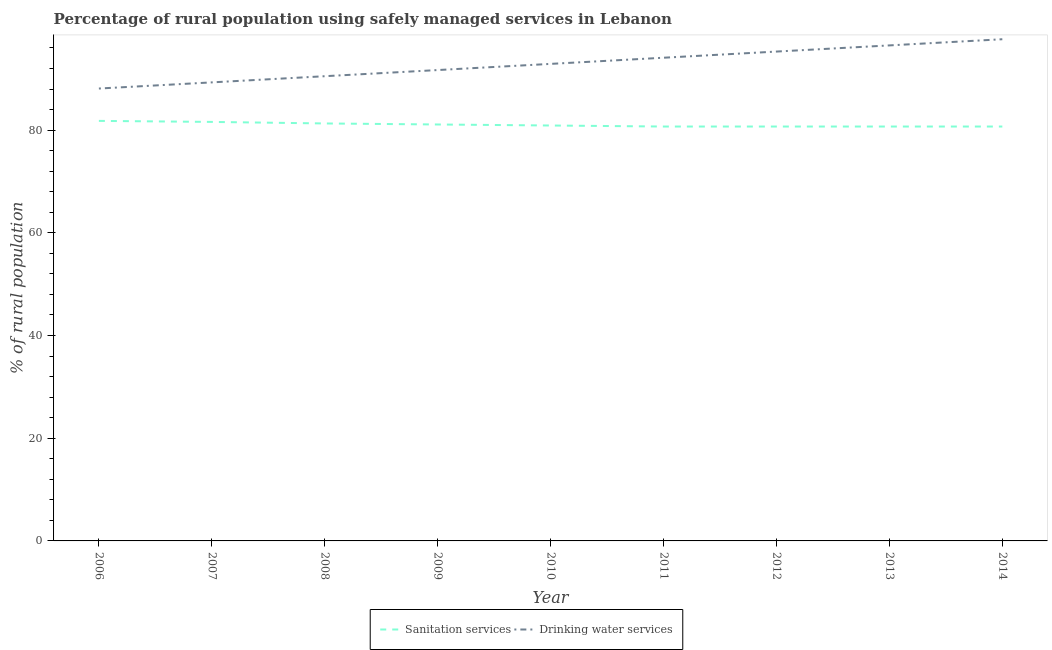How many different coloured lines are there?
Give a very brief answer. 2. Is the number of lines equal to the number of legend labels?
Offer a terse response. Yes. What is the percentage of rural population who used sanitation services in 2010?
Offer a terse response. 80.9. Across all years, what is the maximum percentage of rural population who used drinking water services?
Your answer should be very brief. 97.7. Across all years, what is the minimum percentage of rural population who used drinking water services?
Provide a short and direct response. 88.1. In which year was the percentage of rural population who used drinking water services maximum?
Ensure brevity in your answer.  2014. In which year was the percentage of rural population who used sanitation services minimum?
Your response must be concise. 2011. What is the total percentage of rural population who used sanitation services in the graph?
Your answer should be compact. 729.5. What is the difference between the percentage of rural population who used sanitation services in 2006 and that in 2012?
Keep it short and to the point. 1.1. What is the difference between the percentage of rural population who used drinking water services in 2011 and the percentage of rural population who used sanitation services in 2009?
Your response must be concise. 13. What is the average percentage of rural population who used drinking water services per year?
Offer a terse response. 92.9. In the year 2007, what is the difference between the percentage of rural population who used drinking water services and percentage of rural population who used sanitation services?
Make the answer very short. 7.7. What is the ratio of the percentage of rural population who used sanitation services in 2008 to that in 2014?
Provide a short and direct response. 1.01. Is the percentage of rural population who used drinking water services in 2007 less than that in 2008?
Give a very brief answer. Yes. What is the difference between the highest and the second highest percentage of rural population who used sanitation services?
Ensure brevity in your answer.  0.2. What is the difference between the highest and the lowest percentage of rural population who used drinking water services?
Make the answer very short. 9.6. Does the percentage of rural population who used drinking water services monotonically increase over the years?
Ensure brevity in your answer.  Yes. How many years are there in the graph?
Your answer should be very brief. 9. What is the difference between two consecutive major ticks on the Y-axis?
Keep it short and to the point. 20. Are the values on the major ticks of Y-axis written in scientific E-notation?
Give a very brief answer. No. Does the graph contain any zero values?
Give a very brief answer. No. How are the legend labels stacked?
Provide a short and direct response. Horizontal. What is the title of the graph?
Make the answer very short. Percentage of rural population using safely managed services in Lebanon. Does "Death rate" appear as one of the legend labels in the graph?
Ensure brevity in your answer.  No. What is the label or title of the Y-axis?
Your response must be concise. % of rural population. What is the % of rural population in Sanitation services in 2006?
Ensure brevity in your answer.  81.8. What is the % of rural population of Drinking water services in 2006?
Offer a terse response. 88.1. What is the % of rural population in Sanitation services in 2007?
Your answer should be very brief. 81.6. What is the % of rural population in Drinking water services in 2007?
Ensure brevity in your answer.  89.3. What is the % of rural population in Sanitation services in 2008?
Your answer should be very brief. 81.3. What is the % of rural population in Drinking water services in 2008?
Ensure brevity in your answer.  90.5. What is the % of rural population in Sanitation services in 2009?
Ensure brevity in your answer.  81.1. What is the % of rural population in Drinking water services in 2009?
Your response must be concise. 91.7. What is the % of rural population in Sanitation services in 2010?
Provide a succinct answer. 80.9. What is the % of rural population of Drinking water services in 2010?
Your response must be concise. 92.9. What is the % of rural population in Sanitation services in 2011?
Your response must be concise. 80.7. What is the % of rural population of Drinking water services in 2011?
Your answer should be very brief. 94.1. What is the % of rural population of Sanitation services in 2012?
Provide a succinct answer. 80.7. What is the % of rural population of Drinking water services in 2012?
Offer a terse response. 95.3. What is the % of rural population of Sanitation services in 2013?
Provide a short and direct response. 80.7. What is the % of rural population of Drinking water services in 2013?
Provide a short and direct response. 96.5. What is the % of rural population in Sanitation services in 2014?
Your response must be concise. 80.7. What is the % of rural population in Drinking water services in 2014?
Your answer should be compact. 97.7. Across all years, what is the maximum % of rural population of Sanitation services?
Provide a succinct answer. 81.8. Across all years, what is the maximum % of rural population in Drinking water services?
Offer a very short reply. 97.7. Across all years, what is the minimum % of rural population in Sanitation services?
Keep it short and to the point. 80.7. Across all years, what is the minimum % of rural population of Drinking water services?
Keep it short and to the point. 88.1. What is the total % of rural population of Sanitation services in the graph?
Offer a terse response. 729.5. What is the total % of rural population of Drinking water services in the graph?
Provide a succinct answer. 836.1. What is the difference between the % of rural population of Sanitation services in 2006 and that in 2009?
Ensure brevity in your answer.  0.7. What is the difference between the % of rural population of Drinking water services in 2006 and that in 2009?
Make the answer very short. -3.6. What is the difference between the % of rural population of Sanitation services in 2006 and that in 2010?
Give a very brief answer. 0.9. What is the difference between the % of rural population in Drinking water services in 2006 and that in 2011?
Your answer should be very brief. -6. What is the difference between the % of rural population in Sanitation services in 2006 and that in 2012?
Give a very brief answer. 1.1. What is the difference between the % of rural population in Drinking water services in 2006 and that in 2012?
Ensure brevity in your answer.  -7.2. What is the difference between the % of rural population of Drinking water services in 2007 and that in 2008?
Offer a very short reply. -1.2. What is the difference between the % of rural population in Drinking water services in 2007 and that in 2009?
Ensure brevity in your answer.  -2.4. What is the difference between the % of rural population in Drinking water services in 2007 and that in 2011?
Provide a short and direct response. -4.8. What is the difference between the % of rural population of Sanitation services in 2007 and that in 2012?
Give a very brief answer. 0.9. What is the difference between the % of rural population of Drinking water services in 2007 and that in 2012?
Your answer should be very brief. -6. What is the difference between the % of rural population of Drinking water services in 2007 and that in 2013?
Give a very brief answer. -7.2. What is the difference between the % of rural population in Sanitation services in 2007 and that in 2014?
Your answer should be very brief. 0.9. What is the difference between the % of rural population in Sanitation services in 2008 and that in 2009?
Make the answer very short. 0.2. What is the difference between the % of rural population in Sanitation services in 2008 and that in 2010?
Your answer should be compact. 0.4. What is the difference between the % of rural population in Drinking water services in 2008 and that in 2010?
Give a very brief answer. -2.4. What is the difference between the % of rural population of Sanitation services in 2008 and that in 2011?
Your response must be concise. 0.6. What is the difference between the % of rural population of Drinking water services in 2008 and that in 2011?
Offer a very short reply. -3.6. What is the difference between the % of rural population in Sanitation services in 2008 and that in 2012?
Keep it short and to the point. 0.6. What is the difference between the % of rural population of Drinking water services in 2008 and that in 2014?
Ensure brevity in your answer.  -7.2. What is the difference between the % of rural population in Sanitation services in 2009 and that in 2010?
Keep it short and to the point. 0.2. What is the difference between the % of rural population of Drinking water services in 2009 and that in 2014?
Your response must be concise. -6. What is the difference between the % of rural population in Sanitation services in 2010 and that in 2011?
Give a very brief answer. 0.2. What is the difference between the % of rural population of Drinking water services in 2010 and that in 2011?
Offer a terse response. -1.2. What is the difference between the % of rural population in Sanitation services in 2010 and that in 2013?
Make the answer very short. 0.2. What is the difference between the % of rural population in Drinking water services in 2010 and that in 2013?
Provide a succinct answer. -3.6. What is the difference between the % of rural population of Drinking water services in 2010 and that in 2014?
Offer a very short reply. -4.8. What is the difference between the % of rural population of Sanitation services in 2011 and that in 2012?
Ensure brevity in your answer.  0. What is the difference between the % of rural population of Drinking water services in 2011 and that in 2013?
Your response must be concise. -2.4. What is the difference between the % of rural population of Sanitation services in 2011 and that in 2014?
Offer a terse response. 0. What is the difference between the % of rural population in Drinking water services in 2011 and that in 2014?
Provide a short and direct response. -3.6. What is the difference between the % of rural population of Drinking water services in 2012 and that in 2013?
Provide a short and direct response. -1.2. What is the difference between the % of rural population in Sanitation services in 2013 and that in 2014?
Your answer should be very brief. 0. What is the difference between the % of rural population of Sanitation services in 2006 and the % of rural population of Drinking water services in 2008?
Make the answer very short. -8.7. What is the difference between the % of rural population of Sanitation services in 2006 and the % of rural population of Drinking water services in 2009?
Offer a terse response. -9.9. What is the difference between the % of rural population in Sanitation services in 2006 and the % of rural population in Drinking water services in 2010?
Offer a very short reply. -11.1. What is the difference between the % of rural population of Sanitation services in 2006 and the % of rural population of Drinking water services in 2013?
Make the answer very short. -14.7. What is the difference between the % of rural population in Sanitation services in 2006 and the % of rural population in Drinking water services in 2014?
Your answer should be very brief. -15.9. What is the difference between the % of rural population in Sanitation services in 2007 and the % of rural population in Drinking water services in 2008?
Make the answer very short. -8.9. What is the difference between the % of rural population of Sanitation services in 2007 and the % of rural population of Drinking water services in 2011?
Keep it short and to the point. -12.5. What is the difference between the % of rural population of Sanitation services in 2007 and the % of rural population of Drinking water services in 2012?
Your response must be concise. -13.7. What is the difference between the % of rural population of Sanitation services in 2007 and the % of rural population of Drinking water services in 2013?
Offer a very short reply. -14.9. What is the difference between the % of rural population of Sanitation services in 2007 and the % of rural population of Drinking water services in 2014?
Keep it short and to the point. -16.1. What is the difference between the % of rural population of Sanitation services in 2008 and the % of rural population of Drinking water services in 2010?
Provide a succinct answer. -11.6. What is the difference between the % of rural population of Sanitation services in 2008 and the % of rural population of Drinking water services in 2013?
Offer a terse response. -15.2. What is the difference between the % of rural population of Sanitation services in 2008 and the % of rural population of Drinking water services in 2014?
Your response must be concise. -16.4. What is the difference between the % of rural population in Sanitation services in 2009 and the % of rural population in Drinking water services in 2013?
Offer a very short reply. -15.4. What is the difference between the % of rural population of Sanitation services in 2009 and the % of rural population of Drinking water services in 2014?
Keep it short and to the point. -16.6. What is the difference between the % of rural population in Sanitation services in 2010 and the % of rural population in Drinking water services in 2012?
Offer a terse response. -14.4. What is the difference between the % of rural population of Sanitation services in 2010 and the % of rural population of Drinking water services in 2013?
Offer a very short reply. -15.6. What is the difference between the % of rural population of Sanitation services in 2010 and the % of rural population of Drinking water services in 2014?
Provide a short and direct response. -16.8. What is the difference between the % of rural population of Sanitation services in 2011 and the % of rural population of Drinking water services in 2012?
Provide a short and direct response. -14.6. What is the difference between the % of rural population in Sanitation services in 2011 and the % of rural population in Drinking water services in 2013?
Your answer should be very brief. -15.8. What is the difference between the % of rural population in Sanitation services in 2011 and the % of rural population in Drinking water services in 2014?
Your response must be concise. -17. What is the difference between the % of rural population in Sanitation services in 2012 and the % of rural population in Drinking water services in 2013?
Offer a terse response. -15.8. What is the average % of rural population of Sanitation services per year?
Your answer should be very brief. 81.06. What is the average % of rural population in Drinking water services per year?
Provide a succinct answer. 92.9. In the year 2006, what is the difference between the % of rural population in Sanitation services and % of rural population in Drinking water services?
Offer a very short reply. -6.3. In the year 2010, what is the difference between the % of rural population in Sanitation services and % of rural population in Drinking water services?
Make the answer very short. -12. In the year 2011, what is the difference between the % of rural population of Sanitation services and % of rural population of Drinking water services?
Make the answer very short. -13.4. In the year 2012, what is the difference between the % of rural population in Sanitation services and % of rural population in Drinking water services?
Offer a terse response. -14.6. In the year 2013, what is the difference between the % of rural population in Sanitation services and % of rural population in Drinking water services?
Your response must be concise. -15.8. In the year 2014, what is the difference between the % of rural population in Sanitation services and % of rural population in Drinking water services?
Give a very brief answer. -17. What is the ratio of the % of rural population in Drinking water services in 2006 to that in 2007?
Provide a short and direct response. 0.99. What is the ratio of the % of rural population in Sanitation services in 2006 to that in 2008?
Offer a very short reply. 1.01. What is the ratio of the % of rural population in Drinking water services in 2006 to that in 2008?
Make the answer very short. 0.97. What is the ratio of the % of rural population of Sanitation services in 2006 to that in 2009?
Offer a very short reply. 1.01. What is the ratio of the % of rural population in Drinking water services in 2006 to that in 2009?
Ensure brevity in your answer.  0.96. What is the ratio of the % of rural population in Sanitation services in 2006 to that in 2010?
Offer a very short reply. 1.01. What is the ratio of the % of rural population of Drinking water services in 2006 to that in 2010?
Offer a terse response. 0.95. What is the ratio of the % of rural population in Sanitation services in 2006 to that in 2011?
Offer a terse response. 1.01. What is the ratio of the % of rural population in Drinking water services in 2006 to that in 2011?
Make the answer very short. 0.94. What is the ratio of the % of rural population of Sanitation services in 2006 to that in 2012?
Offer a terse response. 1.01. What is the ratio of the % of rural population of Drinking water services in 2006 to that in 2012?
Your answer should be very brief. 0.92. What is the ratio of the % of rural population of Sanitation services in 2006 to that in 2013?
Your response must be concise. 1.01. What is the ratio of the % of rural population of Sanitation services in 2006 to that in 2014?
Ensure brevity in your answer.  1.01. What is the ratio of the % of rural population in Drinking water services in 2006 to that in 2014?
Keep it short and to the point. 0.9. What is the ratio of the % of rural population of Drinking water services in 2007 to that in 2008?
Provide a short and direct response. 0.99. What is the ratio of the % of rural population in Sanitation services in 2007 to that in 2009?
Provide a succinct answer. 1.01. What is the ratio of the % of rural population of Drinking water services in 2007 to that in 2009?
Your answer should be very brief. 0.97. What is the ratio of the % of rural population in Sanitation services in 2007 to that in 2010?
Offer a terse response. 1.01. What is the ratio of the % of rural population in Drinking water services in 2007 to that in 2010?
Ensure brevity in your answer.  0.96. What is the ratio of the % of rural population in Sanitation services in 2007 to that in 2011?
Keep it short and to the point. 1.01. What is the ratio of the % of rural population of Drinking water services in 2007 to that in 2011?
Offer a terse response. 0.95. What is the ratio of the % of rural population of Sanitation services in 2007 to that in 2012?
Give a very brief answer. 1.01. What is the ratio of the % of rural population of Drinking water services in 2007 to that in 2012?
Your response must be concise. 0.94. What is the ratio of the % of rural population of Sanitation services in 2007 to that in 2013?
Your answer should be very brief. 1.01. What is the ratio of the % of rural population of Drinking water services in 2007 to that in 2013?
Offer a very short reply. 0.93. What is the ratio of the % of rural population of Sanitation services in 2007 to that in 2014?
Offer a terse response. 1.01. What is the ratio of the % of rural population in Drinking water services in 2007 to that in 2014?
Ensure brevity in your answer.  0.91. What is the ratio of the % of rural population of Drinking water services in 2008 to that in 2009?
Keep it short and to the point. 0.99. What is the ratio of the % of rural population of Drinking water services in 2008 to that in 2010?
Your answer should be very brief. 0.97. What is the ratio of the % of rural population of Sanitation services in 2008 to that in 2011?
Your answer should be very brief. 1.01. What is the ratio of the % of rural population in Drinking water services in 2008 to that in 2011?
Make the answer very short. 0.96. What is the ratio of the % of rural population of Sanitation services in 2008 to that in 2012?
Your answer should be very brief. 1.01. What is the ratio of the % of rural population of Drinking water services in 2008 to that in 2012?
Your answer should be compact. 0.95. What is the ratio of the % of rural population in Sanitation services in 2008 to that in 2013?
Your answer should be compact. 1.01. What is the ratio of the % of rural population of Drinking water services in 2008 to that in 2013?
Provide a succinct answer. 0.94. What is the ratio of the % of rural population in Sanitation services in 2008 to that in 2014?
Provide a succinct answer. 1.01. What is the ratio of the % of rural population of Drinking water services in 2008 to that in 2014?
Your answer should be very brief. 0.93. What is the ratio of the % of rural population in Sanitation services in 2009 to that in 2010?
Ensure brevity in your answer.  1. What is the ratio of the % of rural population of Drinking water services in 2009 to that in 2010?
Your answer should be very brief. 0.99. What is the ratio of the % of rural population of Drinking water services in 2009 to that in 2011?
Your response must be concise. 0.97. What is the ratio of the % of rural population of Sanitation services in 2009 to that in 2012?
Offer a very short reply. 1. What is the ratio of the % of rural population of Drinking water services in 2009 to that in 2012?
Provide a succinct answer. 0.96. What is the ratio of the % of rural population of Sanitation services in 2009 to that in 2013?
Offer a terse response. 1. What is the ratio of the % of rural population of Drinking water services in 2009 to that in 2013?
Give a very brief answer. 0.95. What is the ratio of the % of rural population in Drinking water services in 2009 to that in 2014?
Provide a short and direct response. 0.94. What is the ratio of the % of rural population of Sanitation services in 2010 to that in 2011?
Make the answer very short. 1. What is the ratio of the % of rural population of Drinking water services in 2010 to that in 2011?
Offer a very short reply. 0.99. What is the ratio of the % of rural population of Sanitation services in 2010 to that in 2012?
Make the answer very short. 1. What is the ratio of the % of rural population of Drinking water services in 2010 to that in 2012?
Your answer should be very brief. 0.97. What is the ratio of the % of rural population in Drinking water services in 2010 to that in 2013?
Provide a short and direct response. 0.96. What is the ratio of the % of rural population of Sanitation services in 2010 to that in 2014?
Make the answer very short. 1. What is the ratio of the % of rural population of Drinking water services in 2010 to that in 2014?
Make the answer very short. 0.95. What is the ratio of the % of rural population in Sanitation services in 2011 to that in 2012?
Keep it short and to the point. 1. What is the ratio of the % of rural population in Drinking water services in 2011 to that in 2012?
Your answer should be very brief. 0.99. What is the ratio of the % of rural population in Sanitation services in 2011 to that in 2013?
Provide a succinct answer. 1. What is the ratio of the % of rural population of Drinking water services in 2011 to that in 2013?
Your answer should be compact. 0.98. What is the ratio of the % of rural population of Sanitation services in 2011 to that in 2014?
Provide a short and direct response. 1. What is the ratio of the % of rural population in Drinking water services in 2011 to that in 2014?
Give a very brief answer. 0.96. What is the ratio of the % of rural population of Drinking water services in 2012 to that in 2013?
Provide a succinct answer. 0.99. What is the ratio of the % of rural population of Sanitation services in 2012 to that in 2014?
Keep it short and to the point. 1. What is the ratio of the % of rural population of Drinking water services in 2012 to that in 2014?
Your response must be concise. 0.98. What is the ratio of the % of rural population of Drinking water services in 2013 to that in 2014?
Keep it short and to the point. 0.99. What is the difference between the highest and the lowest % of rural population of Sanitation services?
Provide a short and direct response. 1.1. 